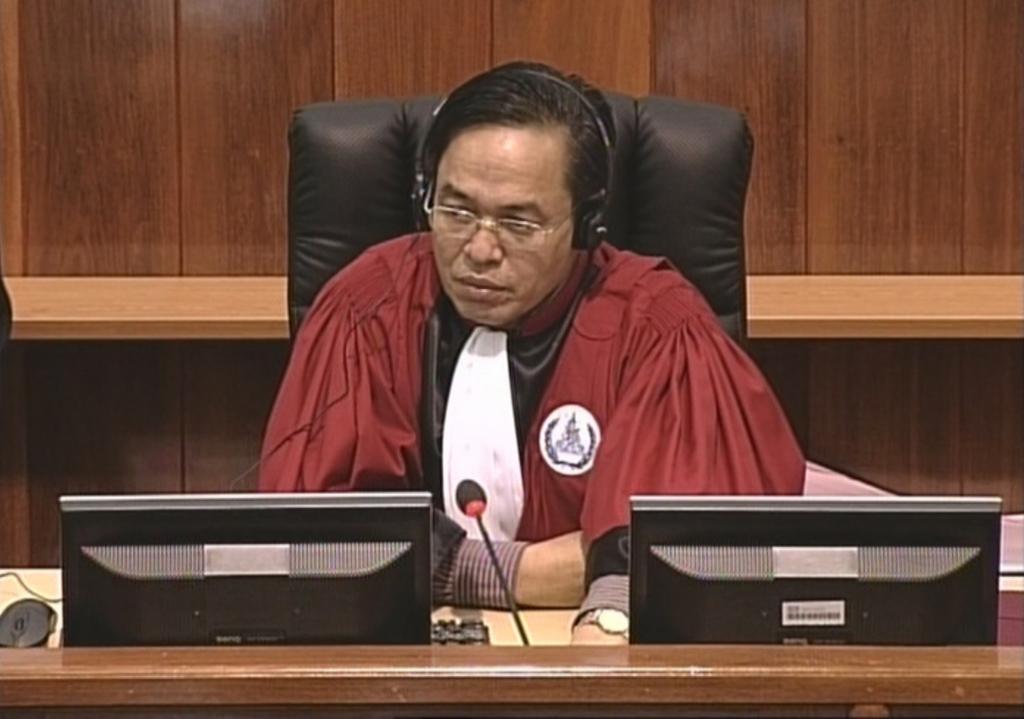How would you summarize this image in a sentence or two? In this picture there is a man sitting on chair in front of a table. He is wearing a red jacket, spectacle and headphones. On the table there are monitors, keyboard, mouse, cables and microphones. In the background there is a wooden wall. 